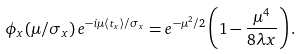Convert formula to latex. <formula><loc_0><loc_0><loc_500><loc_500>\phi _ { x } ( \mu / \sigma _ { x } ) \, e ^ { - i \mu \langle t _ { x } \rangle / \sigma _ { x } } = e ^ { - \mu ^ { 2 } / 2 } \left ( 1 - \frac { \mu ^ { 4 } } { 8 \lambda x } \right ) .</formula> 